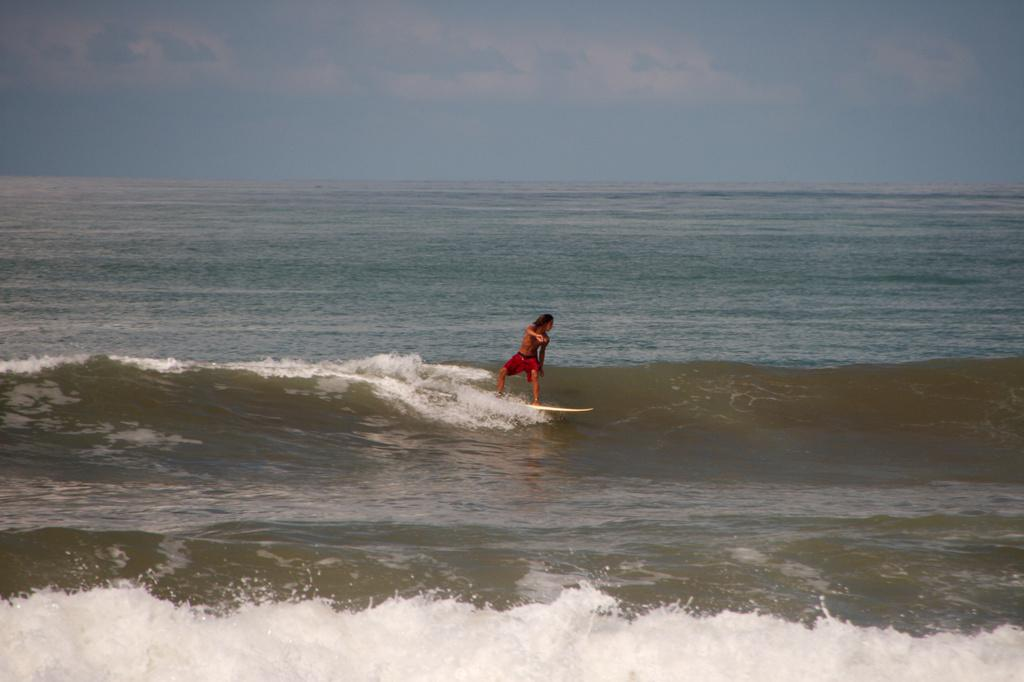What is the person in the image doing? The person is surfing in the image. Where is the person surfing? The person is in the sea. What can be seen in the background of the image? There is sky visible in the background of the image. What is the condition of the sky in the image? Clouds are present in the sky. How does the person's belief in wealth affect their surfing performance in the image? There is no information about the person's beliefs or wealth in the image, so it cannot be determined how these factors might affect their surfing performance. 